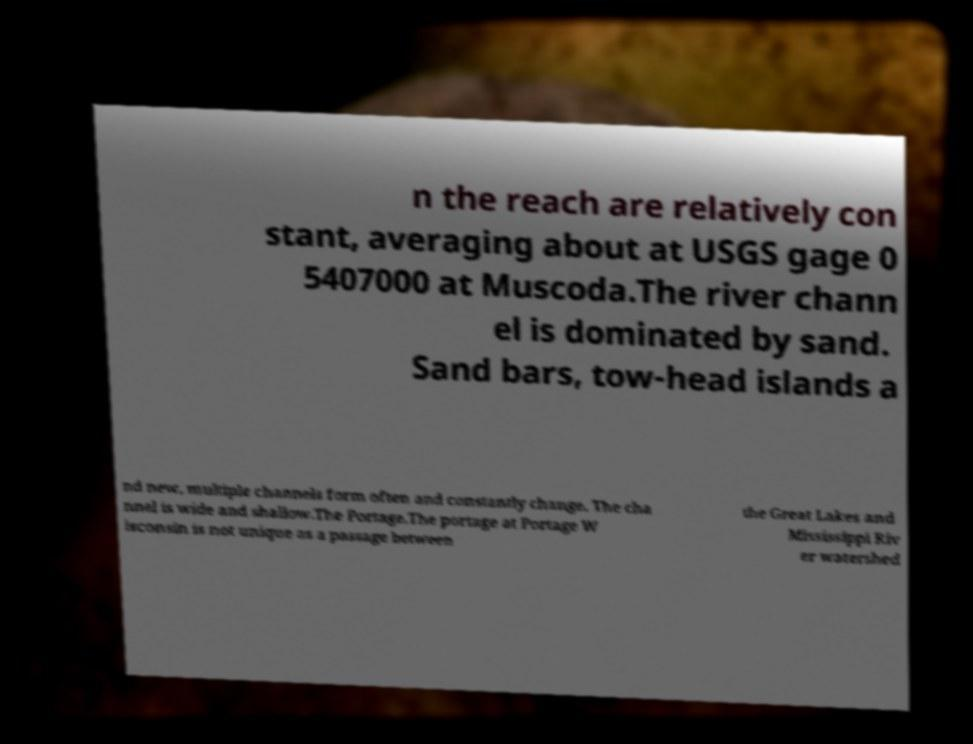Can you accurately transcribe the text from the provided image for me? n the reach are relatively con stant, averaging about at USGS gage 0 5407000 at Muscoda.The river chann el is dominated by sand. Sand bars, tow-head islands a nd new, multiple channels form often and constantly change. The cha nnel is wide and shallow.The Portage.The portage at Portage W isconsin is not unique as a passage between the Great Lakes and Mississippi Riv er watershed 